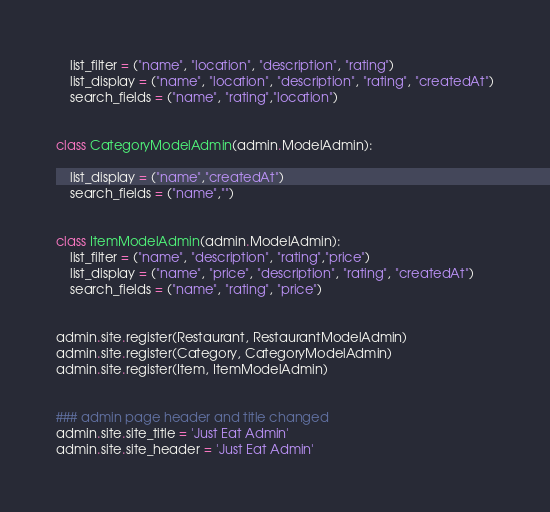<code> <loc_0><loc_0><loc_500><loc_500><_Python_>    list_filter = ("name", "location", "description", "rating")
    list_display = ("name", "location", "description", "rating", "createdAt")
    search_fields = ("name", "rating","location")


class CategoryModelAdmin(admin.ModelAdmin):
    
    list_display = ("name","createdAt")
    search_fields = ("name","")


class ItemModelAdmin(admin.ModelAdmin):
    list_filter = ("name", "description", "rating","price")
    list_display = ("name", "price", "description", "rating", "createdAt")
    search_fields = ("name", "rating", "price")
   

admin.site.register(Restaurant, RestaurantModelAdmin)
admin.site.register(Category, CategoryModelAdmin)
admin.site.register(Item, ItemModelAdmin)


### admin page header and title changed
admin.site.site_title = 'Just Eat Admin'
admin.site.site_header = 'Just Eat Admin'
</code> 